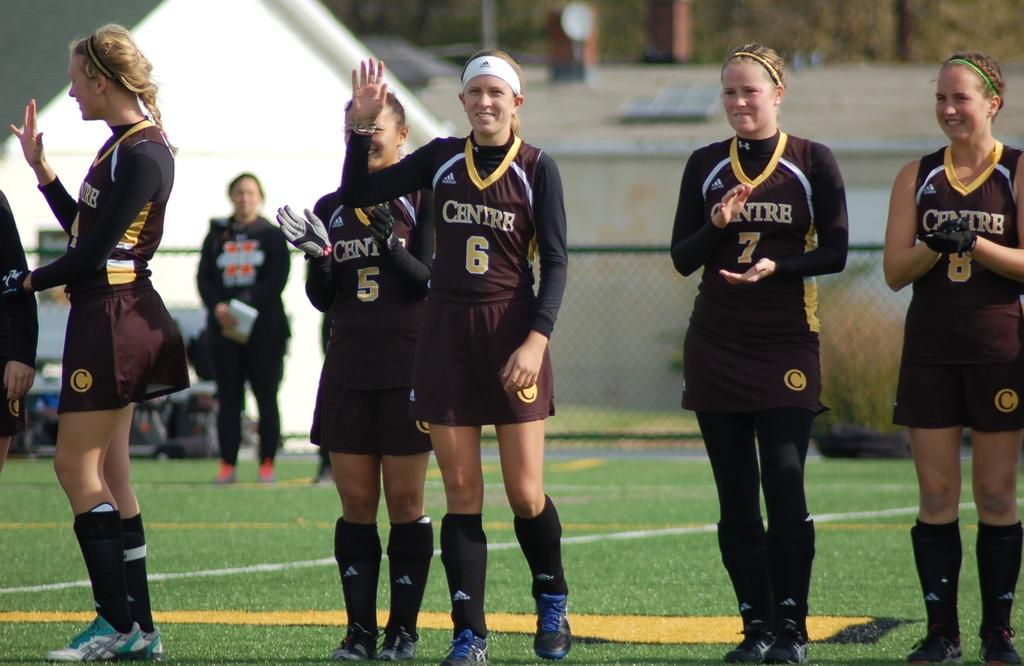<image>
Share a concise interpretation of the image provided. A group of girls wearing black uniforms with Centre on them applaud and wave on a sports pitch. 